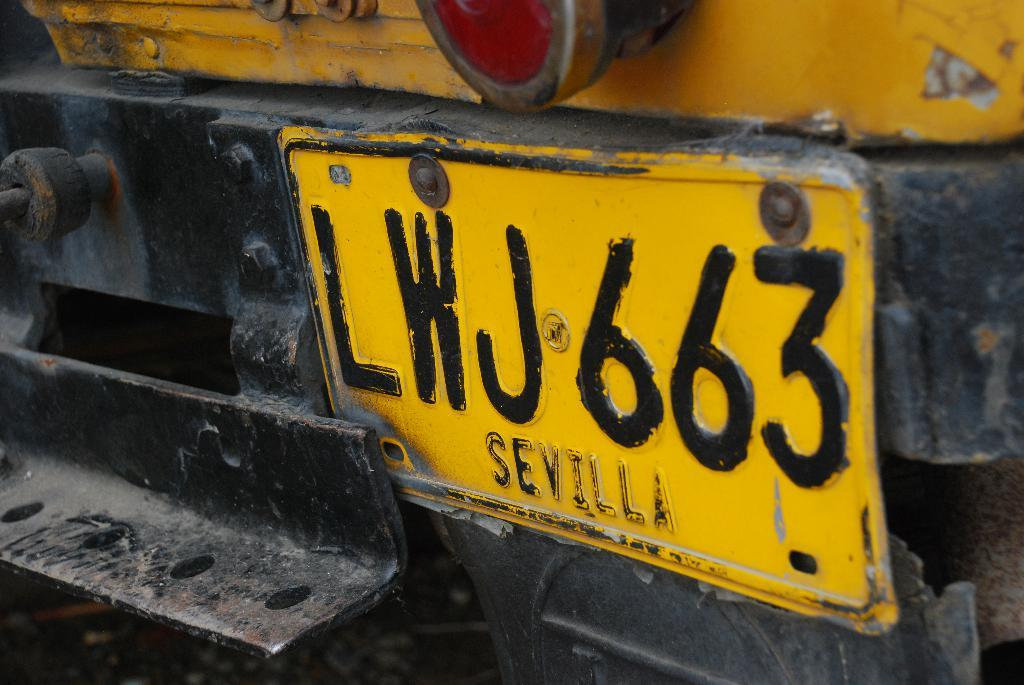Provide a one-sentence caption for the provided image. A license plate with the number LWJ663 says Sevilla at the bottom. 